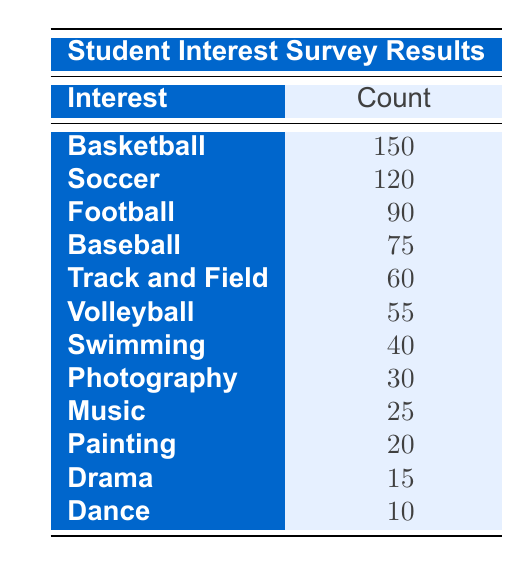What sport has the highest interest among students? The table shows the count of student interest in various sports and arts programs. By comparing the counts, Basketball has the highest count at 150.
Answer: Basketball How many students are interested in Painting? The table lists Painting with a count of 20, indicating that 20 students expressed interest in this art form.
Answer: 20 What is the total number of students interested in sports? To find the total for sports, we need to sum the counts of all sports interests: 150 (Basketball) + 120 (Soccer) + 90 (Football) + 75 (Baseball) + 60 (Track and Field) + 55 (Volleyball) + 40 (Swimming) = 630.
Answer: 630 Is there more interest in Soccer than in Music? The table indicates that Soccer has a count of 120, while Music has a count of 25. Since 120 is greater than 25, the statement is true.
Answer: Yes What is the difference in student interest between Basketball and Dance? Basketball has a count of 150, and Dance has a count of 10. The difference is 150 - 10 = 140.
Answer: 140 How many students are interested in either Football or Volleyball? Football has 90 students, and Volleyball has 55 students. To find the total interested in either, we add these two values: 90 + 55 = 145.
Answer: 145 What percentage of students are interested in arts programs? The total count for arts (Painting, Drama, Music, Dance, Photography) is 20 + 15 + 25 + 10 + 30 = 100. The total for all interests is 730 (630 sports + 100 arts). The percentage is (100 / 730) * 100 = 13.7%.
Answer: 13.7% Which sport has a count that is two times greater than the interest in Drama? The interest in Drama is 15. Looking at the counts, Football at 90 is two times greater than 15, since 90 / 15 = 6. Therefore, Football has this relationship with Drama.
Answer: Football Are there more students interested in Swimming than in Painting? Swimming has a count of 40, while Painting has a count of 20. Since 40 is greater than 20, the answer is yes.
Answer: Yes 